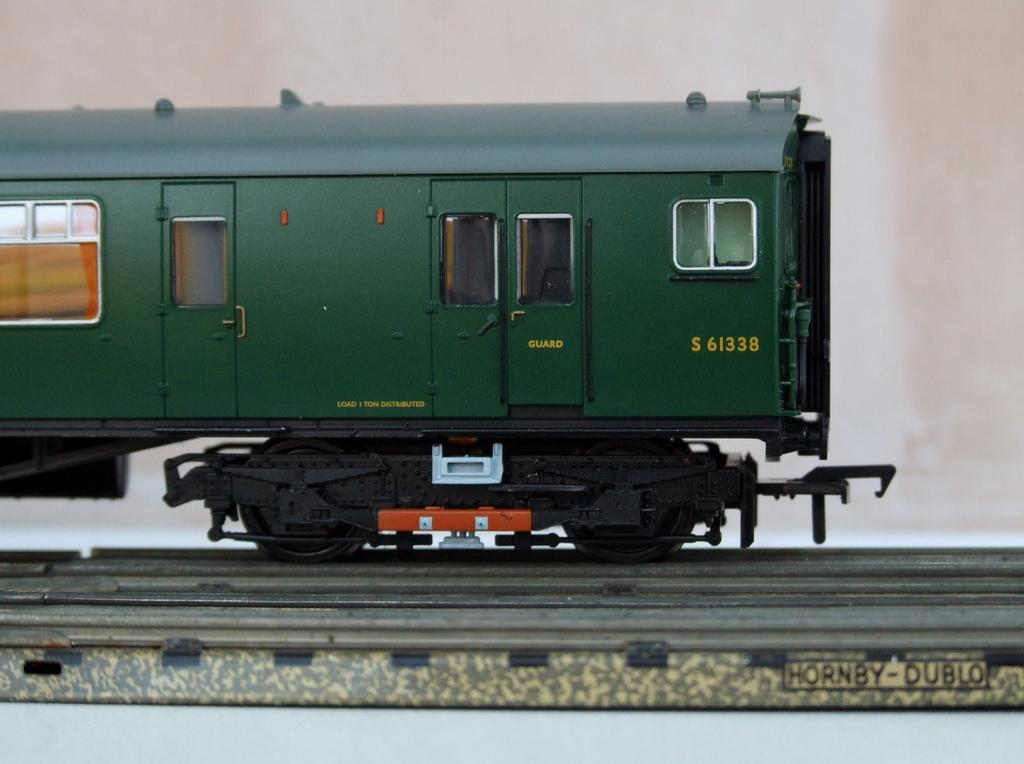What type of vehicle is present in the image? The image contains a miniature train. What is the color of the train? The train is green in color. How many passengers are on the train in the image? There is no indication of passengers on the train in the image, as it is a miniature train. What type of show is being performed with the train in the image? There is no show or performance involving the train in the image; it is simply a miniature train. 